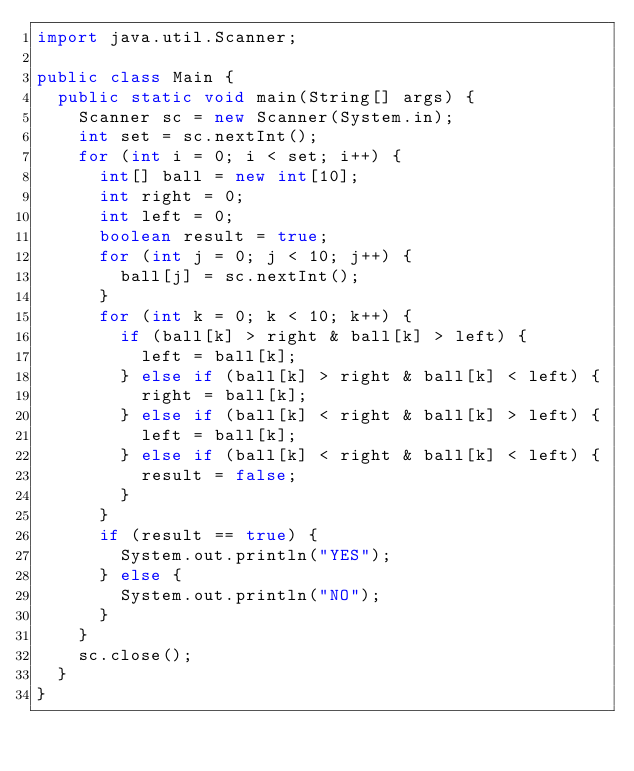Convert code to text. <code><loc_0><loc_0><loc_500><loc_500><_Java_>import java.util.Scanner;

public class Main {
	public static void main(String[] args) {
		Scanner sc = new Scanner(System.in);
		int set = sc.nextInt();
		for (int i = 0; i < set; i++) {
			int[] ball = new int[10];
			int right = 0;
			int left = 0;
			boolean result = true;
			for (int j = 0; j < 10; j++) {
				ball[j] = sc.nextInt();
			}
			for (int k = 0; k < 10; k++) {
				if (ball[k] > right & ball[k] > left) {
					left = ball[k];
				} else if (ball[k] > right & ball[k] < left) {
					right = ball[k];
				} else if (ball[k] < right & ball[k] > left) {
					left = ball[k];
				} else if (ball[k] < right & ball[k] < left) {
					result = false;
				}
			}
			if (result == true) {
				System.out.println("YES");
			} else {
				System.out.println("NO");
			}
		}
		sc.close();
	}
}</code> 